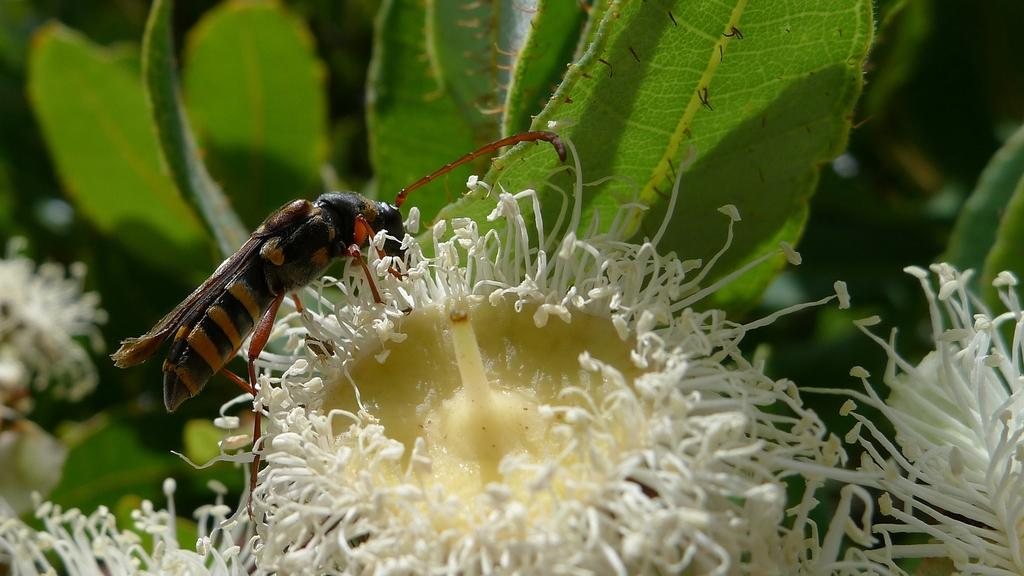What type of plants can be seen in the image? There are flowers and leaves in the image. Can you describe the insect in the image? There is an insect on a flower in the image. What is the background of the image like? The background of the image is blurry. What type of bead is being used by the dad in the image? There is no bead or dad present in the image; it features flowers, leaves, and an insect. What part of the body is visible in the image? There is no body part visible in the image; it focuses on flowers, leaves, and an insect. 